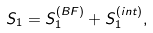Convert formula to latex. <formula><loc_0><loc_0><loc_500><loc_500>S _ { 1 } = S _ { 1 } ^ { \left ( B F \right ) } + S _ { 1 } ^ { \left ( i n t \right ) } ,</formula> 